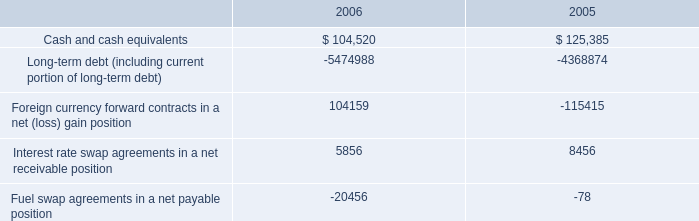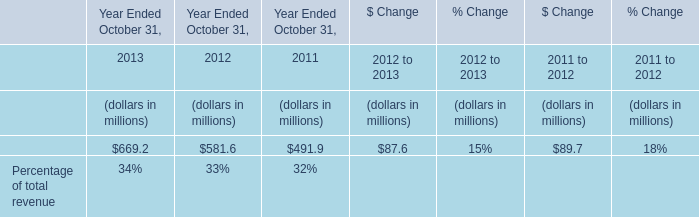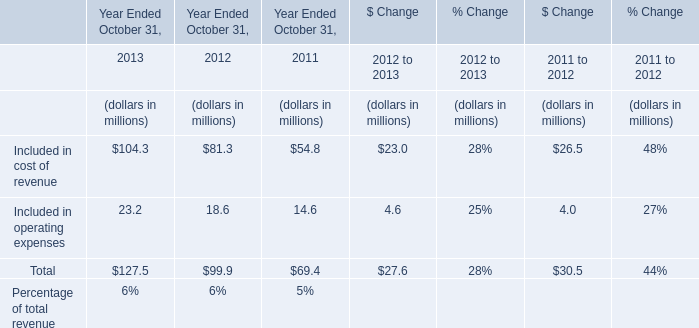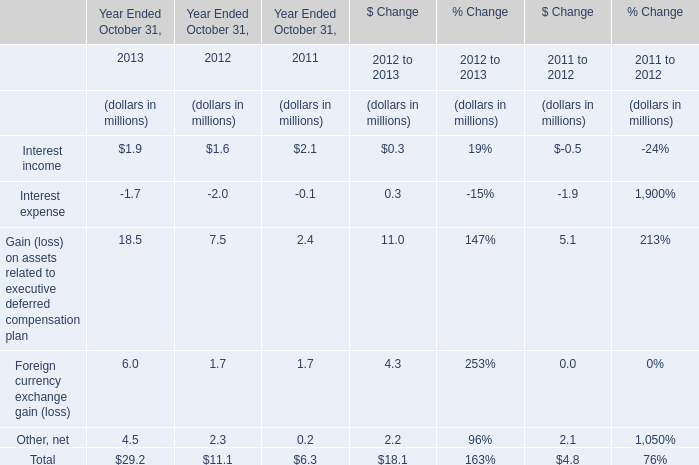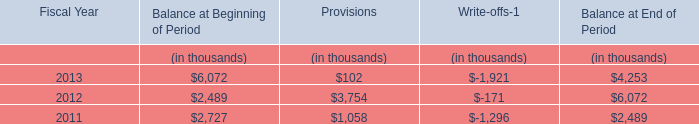As As the chart 2 shows,what's the increasing rate of the value of the "Included in operating expenses" in 2012 Ended October 31? 
Computations: ((18.6 - 14.6) / 14.6)
Answer: 0.27397. 